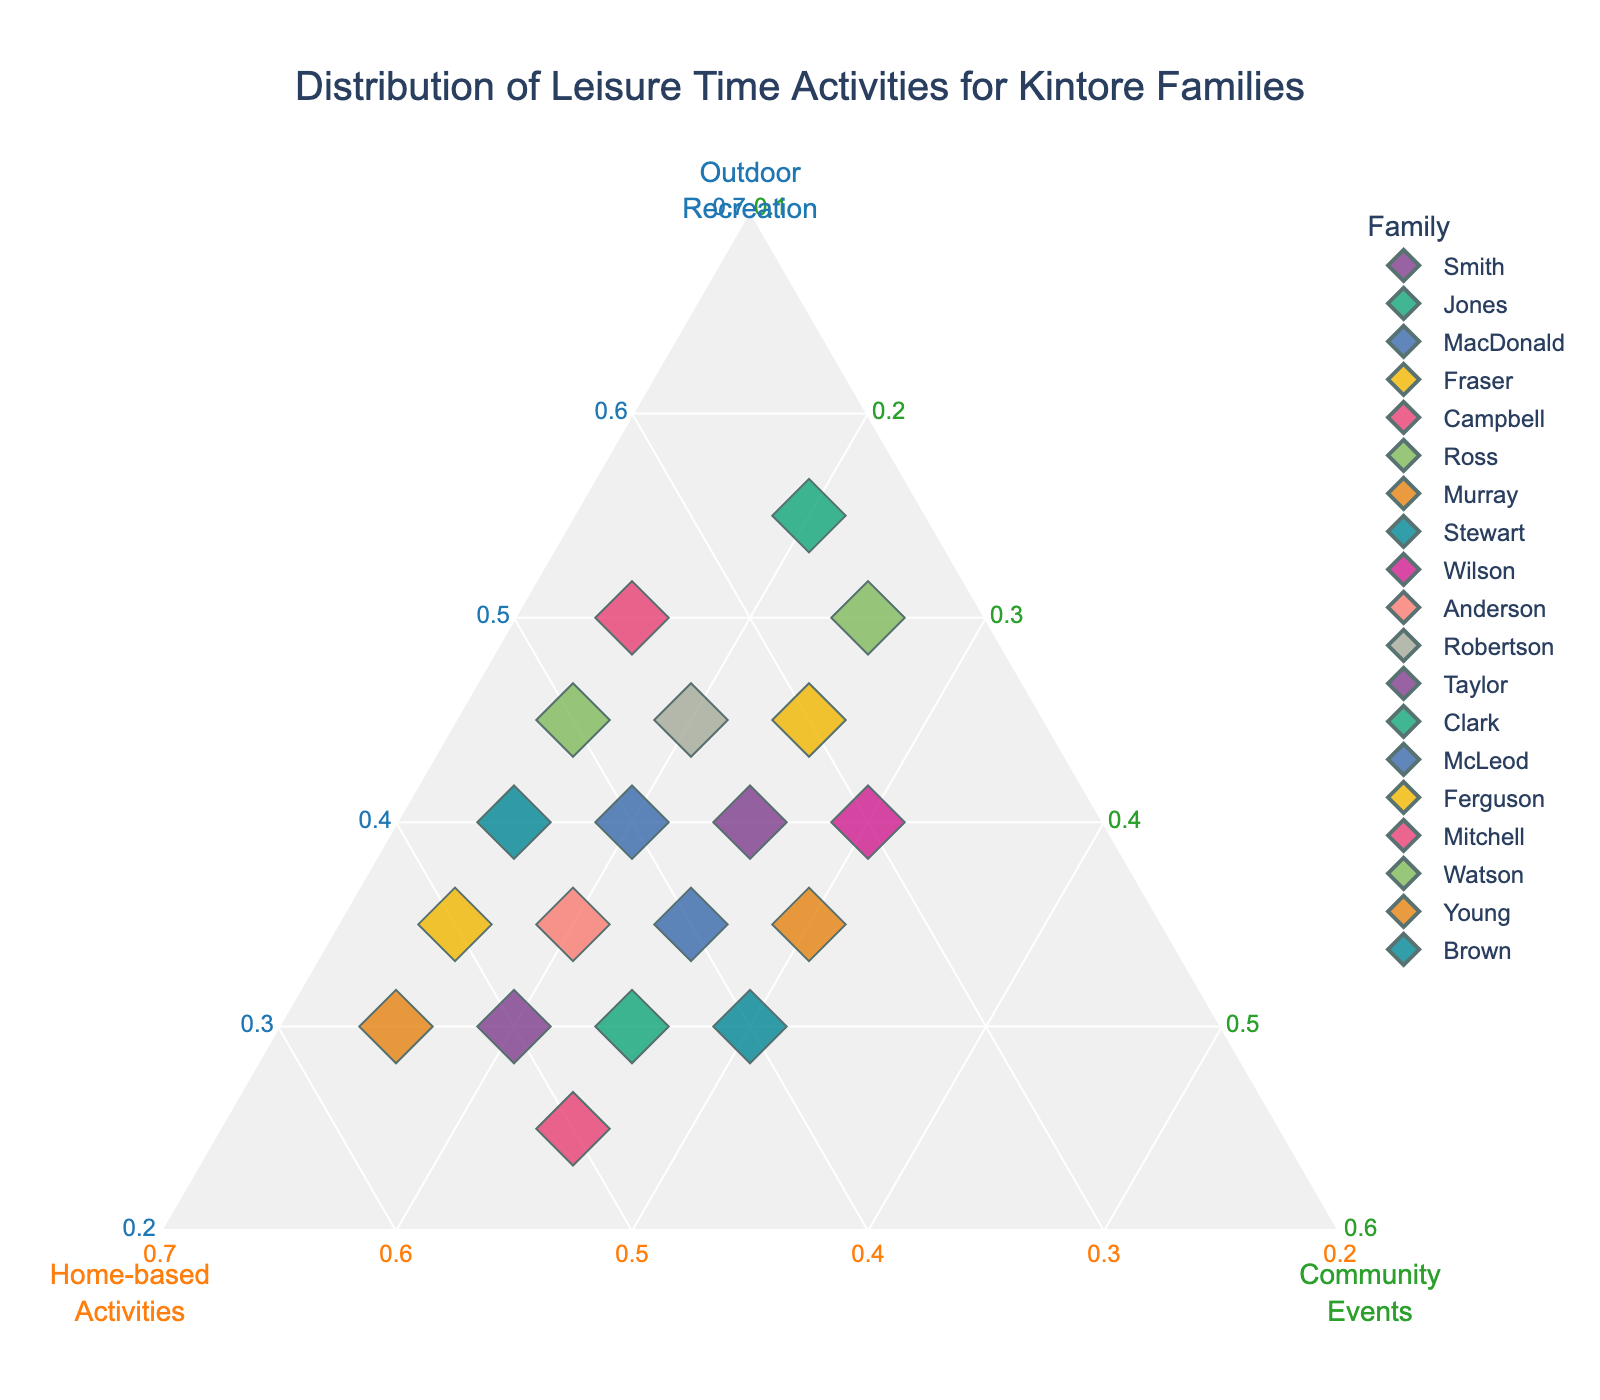Which family spends the highest proportion of their leisure time in Outdoor Recreation? Clark family spends the highest proportion in Outdoor Recreation at 55%. Visual checking of Outdoor Recreation axis, family with the highest value.
Answer: Clark Which families spend an equal proportion of their leisure time between Home-based Activities and Community Events? Identify families with equal proportions on both axes. The equal-haired line helps identify Jones, Campbell, Anderson, Taylor, Ferguson (Home-based:25, Community:25 values).
Answer: Jones, Campbell, Anderson, Taylor, Ferguson What is the average proportion of time spent on Community Events across all families? Sum up all Community Events proportions (25+25+25+25+25+25+30+30+30+20+20+20+15+20+15+15+15+15) = 375, divided by number of families (18).
Answer: 20.8 How many families have Outdoor Recreation greater than 40%? Check families above the 40 values on Outdoor Recreation axis. Smith, Fraser, Ross, Robertson, Clark, Mitchell, Watson.
Answer: 7 Which family has the lowest proportion of time spent on Home-based Activities? Identify the lowest value close to Home-based axis. Clark with 25%.
Answer: Clark 